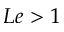Convert formula to latex. <formula><loc_0><loc_0><loc_500><loc_500>L e > 1</formula> 